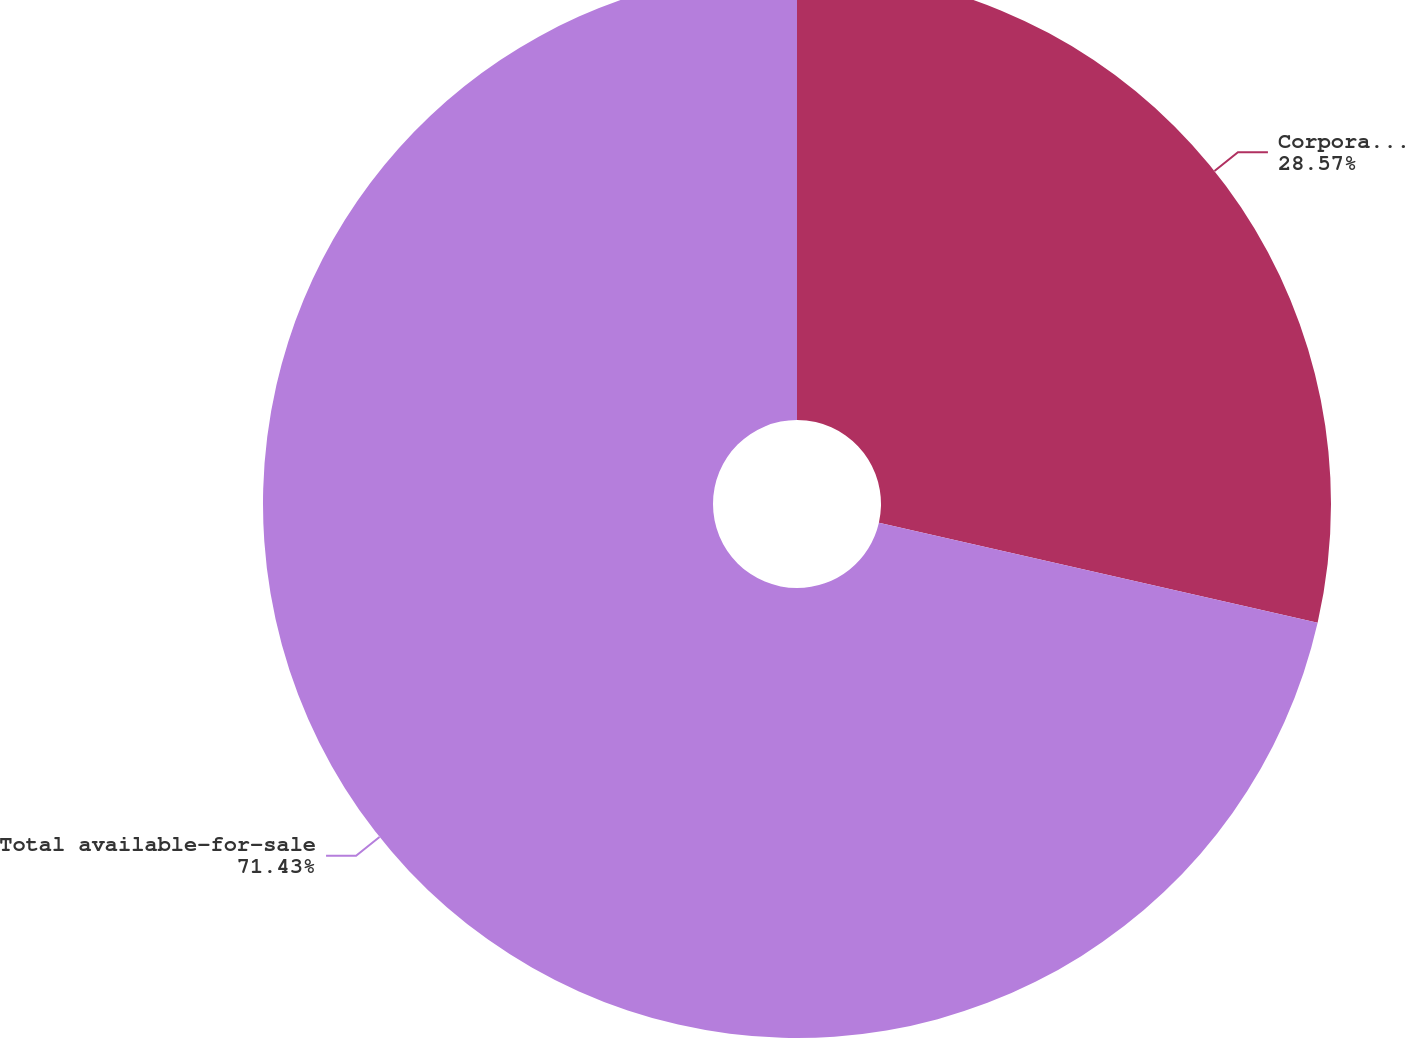Convert chart. <chart><loc_0><loc_0><loc_500><loc_500><pie_chart><fcel>Corporate and asset-backed<fcel>Total available-for-sale<nl><fcel>28.57%<fcel>71.43%<nl></chart> 